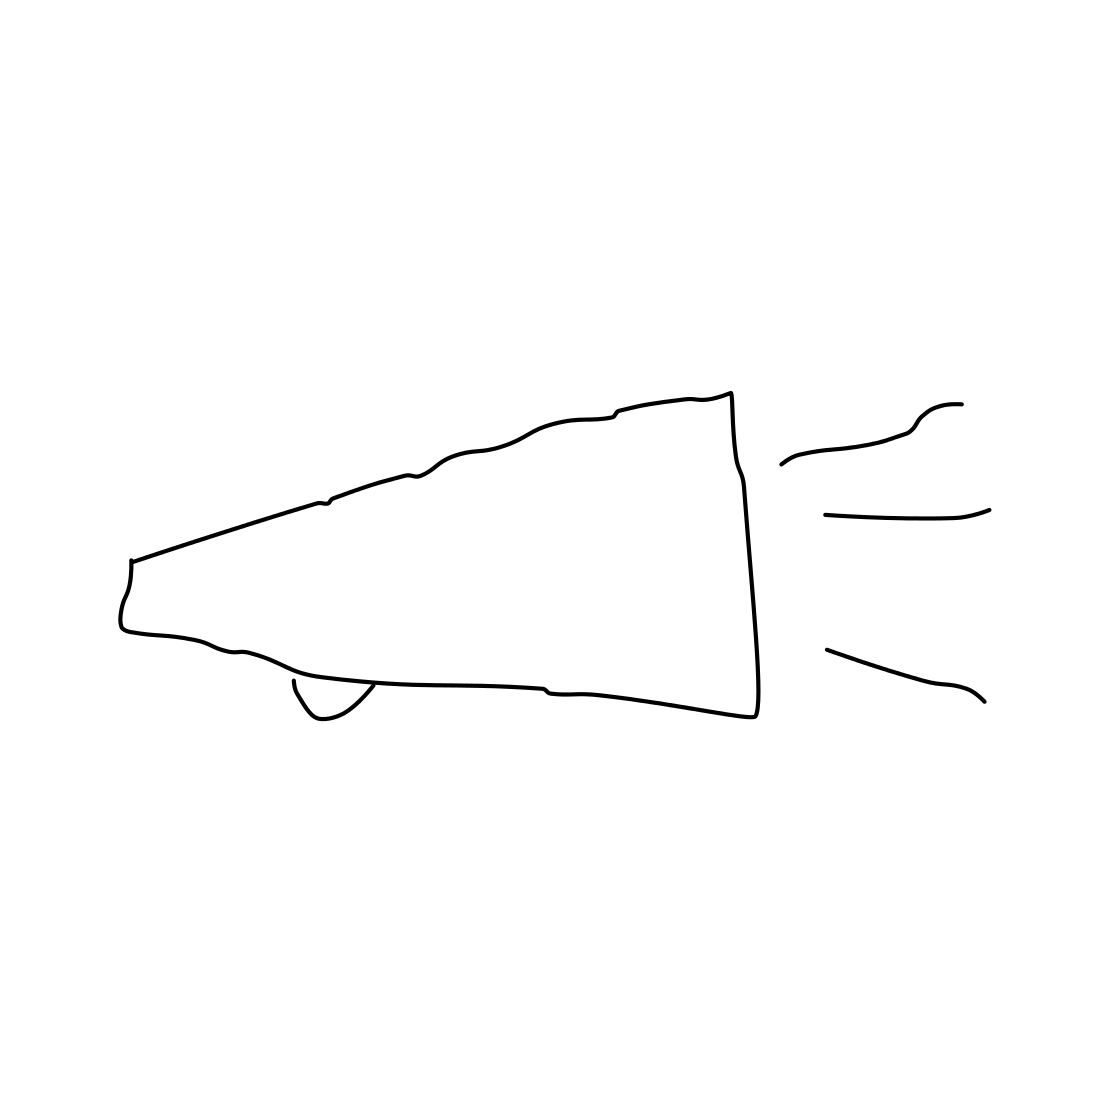Could you describe the style of the drawing? The drawing presents a minimalist and abstract style, focusing on the essential lines to convey the object's form without intricate details or shading. It has a sort of freehand quality to it, which suggests it was drawn quickly or casually. 